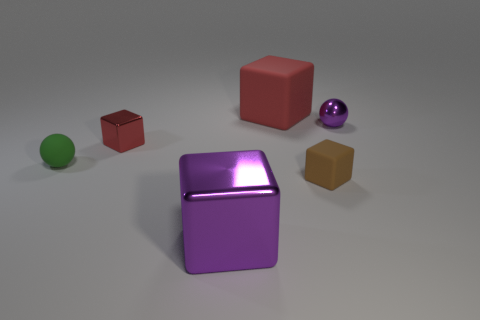How many other objects are there of the same size as the red metal block?
Provide a short and direct response. 3. What is the large object behind the small purple metallic sphere behind the purple object in front of the metal sphere made of?
Ensure brevity in your answer.  Rubber. There is a purple metallic ball; is its size the same as the matte block behind the small purple metallic object?
Ensure brevity in your answer.  No. There is a matte object that is behind the brown rubber thing and in front of the red rubber object; how big is it?
Your answer should be compact. Small. Is there a big rubber object of the same color as the tiny rubber cube?
Give a very brief answer. No. There is a sphere to the left of the ball that is to the right of the tiny brown block; what is its color?
Ensure brevity in your answer.  Green. Is the number of small green rubber spheres that are behind the big red cube less than the number of large shiny cubes that are behind the matte sphere?
Keep it short and to the point. No. Does the red matte thing have the same size as the red metal object?
Make the answer very short. No. What shape is the object that is to the left of the big rubber cube and in front of the tiny green rubber thing?
Offer a very short reply. Cube. What number of tiny brown objects are made of the same material as the tiny purple sphere?
Provide a succinct answer. 0. 